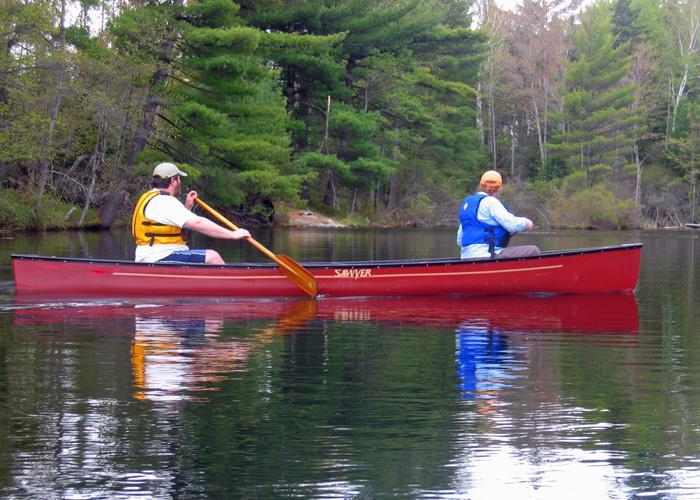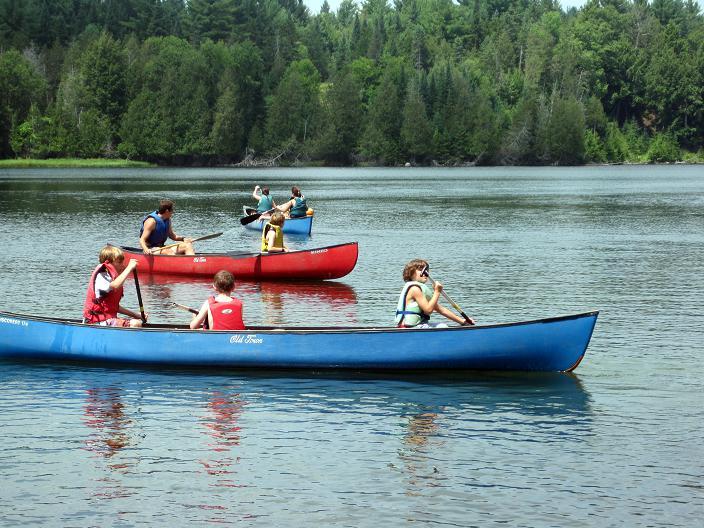The first image is the image on the left, the second image is the image on the right. Evaluate the accuracy of this statement regarding the images: "There is exactly one boat in the image on the right.". Is it true? Answer yes or no. No. 